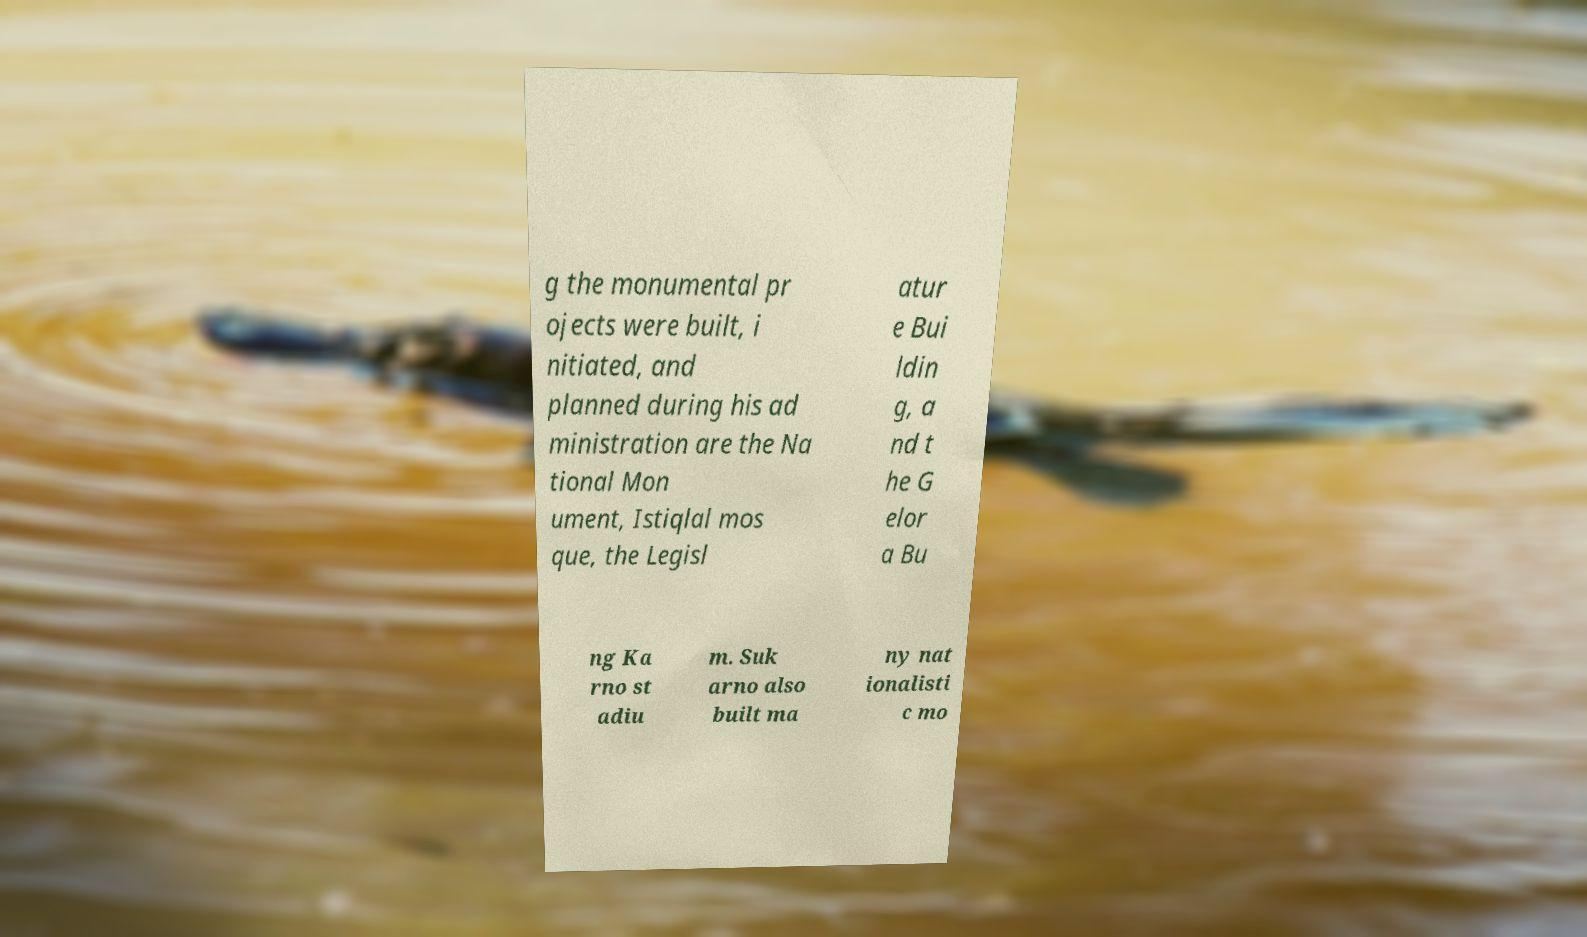For documentation purposes, I need the text within this image transcribed. Could you provide that? g the monumental pr ojects were built, i nitiated, and planned during his ad ministration are the Na tional Mon ument, Istiqlal mos que, the Legisl atur e Bui ldin g, a nd t he G elor a Bu ng Ka rno st adiu m. Suk arno also built ma ny nat ionalisti c mo 